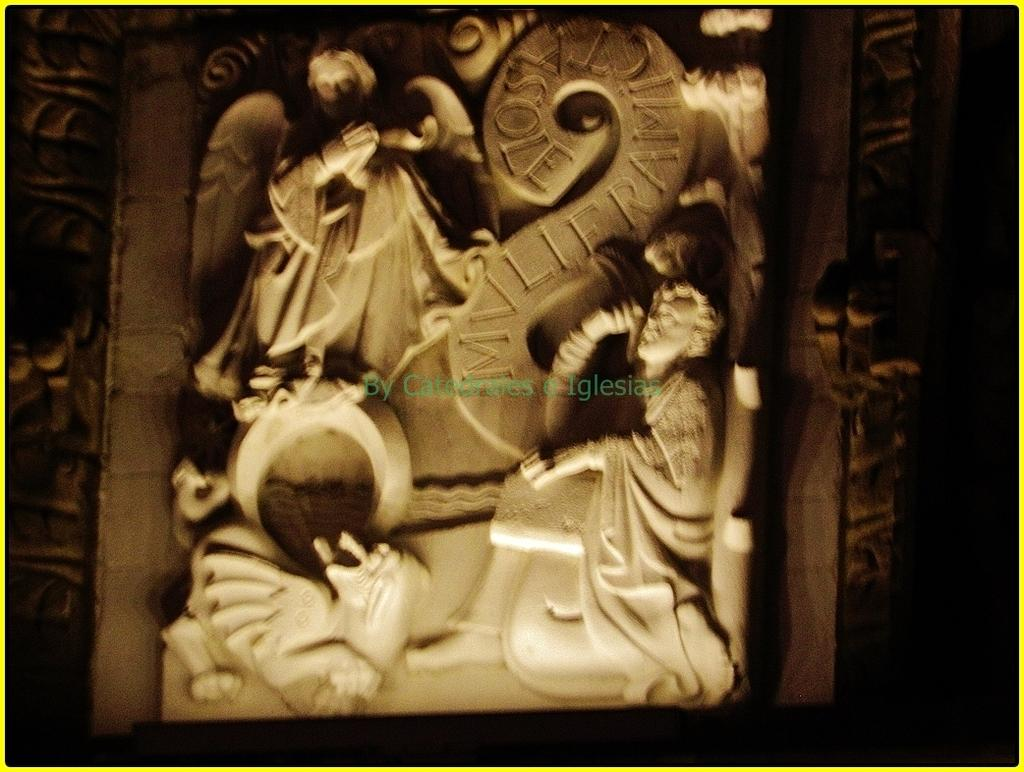What type of artwork can be seen in the image? There are sculptures in the image. Is there any text present in the image? Yes, there is text at the center of the image. What page of the book does the text appear on in the image? There is no book present in the image, so it is not possible to determine which page the text appears on. 